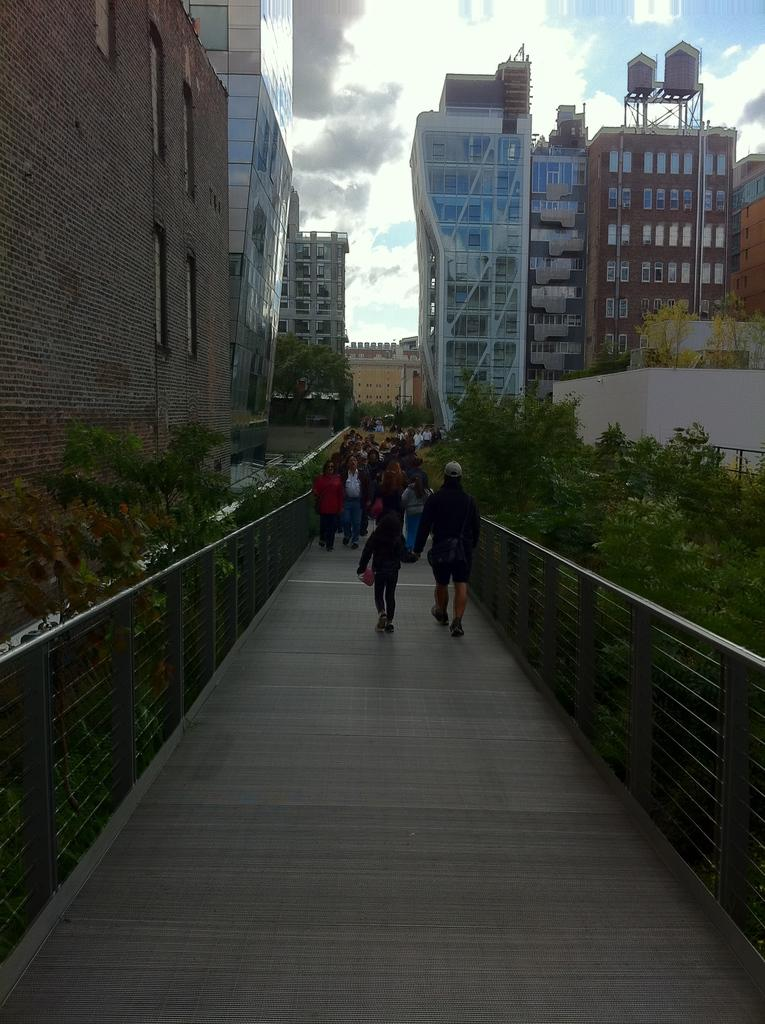What can be seen on the bridge in the image? There are people on the bridge in the image. What is visible in the background behind the bridge? There are trees, buildings, and clouds visible in the background. What type of brake system is installed on the trees in the image? There are no brake systems present on the trees in the image, as trees do not have brake systems. 